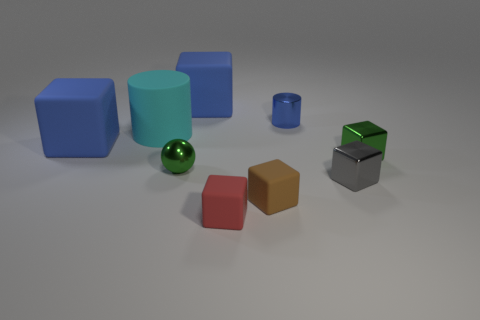What color is the tiny shiny thing that is behind the green sphere and to the right of the metallic cylinder?
Give a very brief answer. Green. Do the green thing right of the gray object and the small blue cylinder that is behind the tiny gray block have the same material?
Offer a terse response. Yes. Is the number of small metallic cylinders on the right side of the cyan rubber cylinder greater than the number of blue matte cubes in front of the small gray object?
Provide a short and direct response. Yes. There is a blue metallic thing that is the same size as the green ball; what is its shape?
Ensure brevity in your answer.  Cylinder. What number of things are either tiny red objects or large things in front of the cyan rubber cylinder?
Your answer should be compact. 2. How many large blue blocks are to the right of the tiny blue cylinder?
Give a very brief answer. 0. What is the color of the cube that is made of the same material as the gray thing?
Your response must be concise. Green. How many metal objects are either big blue blocks or small green things?
Ensure brevity in your answer.  2. Are the gray thing and the small green sphere made of the same material?
Provide a short and direct response. Yes. What shape is the tiny green shiny thing right of the metal cylinder?
Offer a very short reply. Cube. 